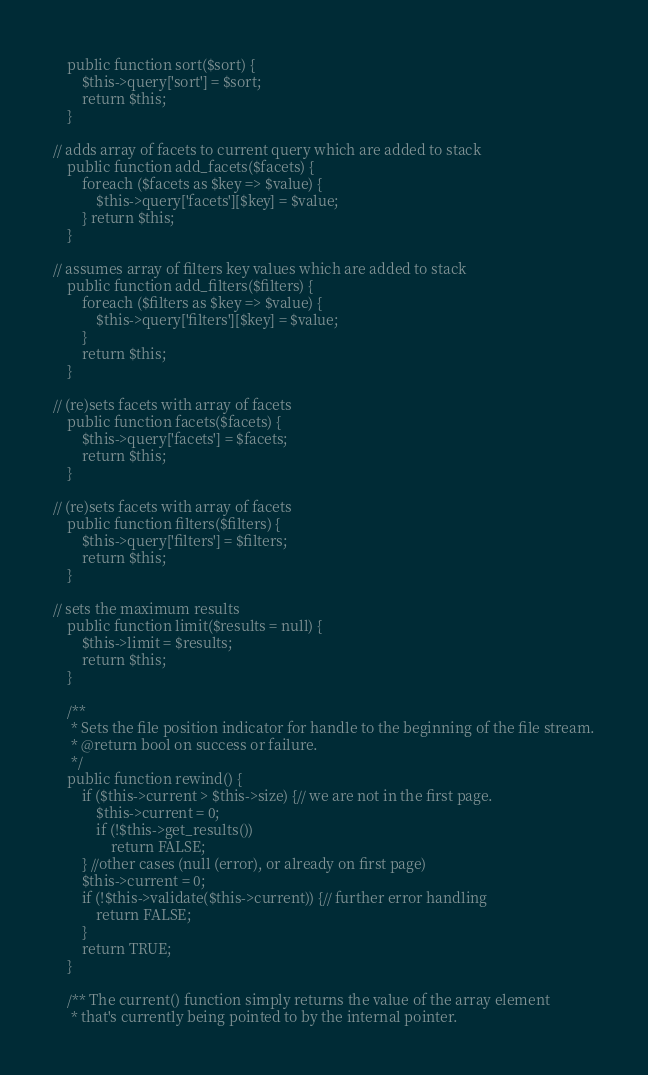<code> <loc_0><loc_0><loc_500><loc_500><_PHP_>    public function sort($sort) {
        $this->query['sort'] = $sort;
        return $this;
    }

// adds array of facets to current query which are added to stack
    public function add_facets($facets) {
        foreach ($facets as $key => $value) {
            $this->query['facets'][$key] = $value;
        } return $this;
    }

// assumes array of filters key values which are added to stack
    public function add_filters($filters) {
        foreach ($filters as $key => $value) {
            $this->query['filters'][$key] = $value;
        }
        return $this;
    }

// (re)sets facets with array of facets
    public function facets($facets) {
        $this->query['facets'] = $facets;
        return $this;
    }

// (re)sets facets with array of facets
    public function filters($filters) {
        $this->query['filters'] = $filters;
        return $this;
    }

// sets the maximum results
    public function limit($results = null) {
        $this->limit = $results;
        return $this;
    }

    /**
     * Sets the file position indicator for handle to the beginning of the file stream.
     * @return bool on success or failure.
     */
    public function rewind() {
        if ($this->current > $this->size) {// we are not in the first page.
            $this->current = 0;
            if (!$this->get_results())
                return FALSE;
        } //other cases (null (error), or already on first page)
        $this->current = 0;
        if (!$this->validate($this->current)) {// further error handling            
            return FALSE;
        }
        return TRUE;
    }

    /** The current() function simply returns the value of the array element 
     * that's currently being pointed to by the internal pointer. </code> 